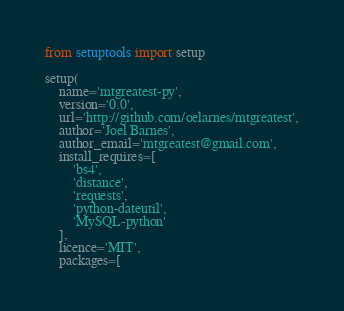<code> <loc_0><loc_0><loc_500><loc_500><_Python_>from setuptools import setup

setup(
    name='mtgreatest-py',
    version='0.0',
    url='http://github.com/oelarnes/mtgreatest',
    author='Joel Barnes',
    author_email='mtgreatest@gmail.com',
    install_requires=[
        'bs4',
        'distance',
        'requests',
        'python-dateutil',
        'MySQL-python'
    ],
    licence='MIT',
    packages=[</code> 